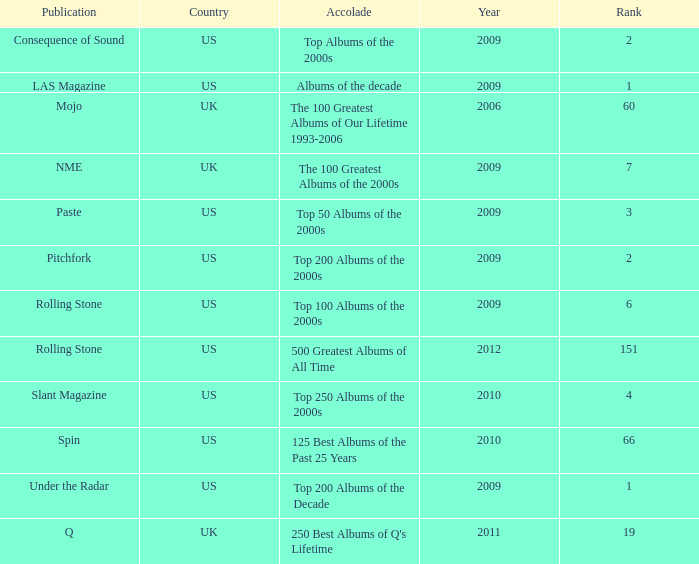In which country was a paste-related publication released in 2009? US. 